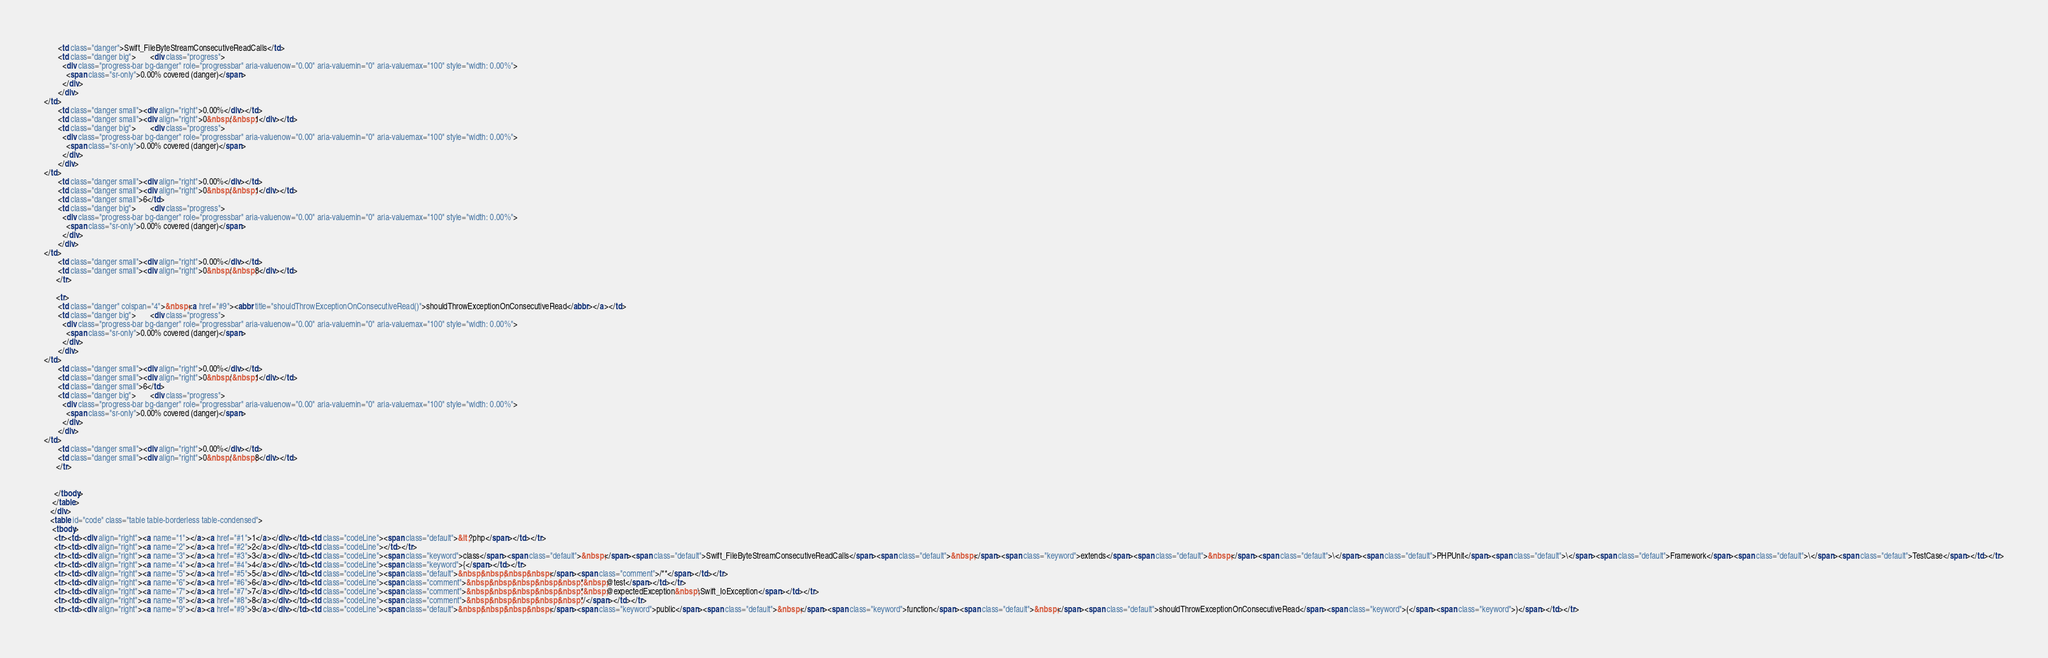Convert code to text. <code><loc_0><loc_0><loc_500><loc_500><_HTML_>       <td class="danger">Swift_FileByteStreamConsecutiveReadCalls</td>
       <td class="danger big">       <div class="progress">
         <div class="progress-bar bg-danger" role="progressbar" aria-valuenow="0.00" aria-valuemin="0" aria-valuemax="100" style="width: 0.00%">
           <span class="sr-only">0.00% covered (danger)</span>
         </div>
       </div>
</td>
       <td class="danger small"><div align="right">0.00%</div></td>
       <td class="danger small"><div align="right">0&nbsp;/&nbsp;1</div></td>
       <td class="danger big">       <div class="progress">
         <div class="progress-bar bg-danger" role="progressbar" aria-valuenow="0.00" aria-valuemin="0" aria-valuemax="100" style="width: 0.00%">
           <span class="sr-only">0.00% covered (danger)</span>
         </div>
       </div>
</td>
       <td class="danger small"><div align="right">0.00%</div></td>
       <td class="danger small"><div align="right">0&nbsp;/&nbsp;1</div></td>
       <td class="danger small">6</td>
       <td class="danger big">       <div class="progress">
         <div class="progress-bar bg-danger" role="progressbar" aria-valuenow="0.00" aria-valuemin="0" aria-valuemax="100" style="width: 0.00%">
           <span class="sr-only">0.00% covered (danger)</span>
         </div>
       </div>
</td>
       <td class="danger small"><div align="right">0.00%</div></td>
       <td class="danger small"><div align="right">0&nbsp;/&nbsp;8</div></td>
      </tr>

      <tr>
       <td class="danger" colspan="4">&nbsp;<a href="#9"><abbr title="shouldThrowExceptionOnConsecutiveRead()">shouldThrowExceptionOnConsecutiveRead</abbr></a></td>
       <td class="danger big">       <div class="progress">
         <div class="progress-bar bg-danger" role="progressbar" aria-valuenow="0.00" aria-valuemin="0" aria-valuemax="100" style="width: 0.00%">
           <span class="sr-only">0.00% covered (danger)</span>
         </div>
       </div>
</td>
       <td class="danger small"><div align="right">0.00%</div></td>
       <td class="danger small"><div align="right">0&nbsp;/&nbsp;1</div></td>
       <td class="danger small">6</td>
       <td class="danger big">       <div class="progress">
         <div class="progress-bar bg-danger" role="progressbar" aria-valuenow="0.00" aria-valuemin="0" aria-valuemax="100" style="width: 0.00%">
           <span class="sr-only">0.00% covered (danger)</span>
         </div>
       </div>
</td>
       <td class="danger small"><div align="right">0.00%</div></td>
       <td class="danger small"><div align="right">0&nbsp;/&nbsp;8</div></td>
      </tr>


     </tbody>
    </table>
   </div>
   <table id="code" class="table table-borderless table-condensed">
    <tbody>
     <tr><td><div align="right"><a name="1"></a><a href="#1">1</a></div></td><td class="codeLine"><span class="default">&lt;?php</span></td></tr>
     <tr><td><div align="right"><a name="2"></a><a href="#2">2</a></div></td><td class="codeLine"></td></tr>
     <tr><td><div align="right"><a name="3"></a><a href="#3">3</a></div></td><td class="codeLine"><span class="keyword">class</span><span class="default">&nbsp;</span><span class="default">Swift_FileByteStreamConsecutiveReadCalls</span><span class="default">&nbsp;</span><span class="keyword">extends</span><span class="default">&nbsp;</span><span class="default">\</span><span class="default">PHPUnit</span><span class="default">\</span><span class="default">Framework</span><span class="default">\</span><span class="default">TestCase</span></td></tr>
     <tr><td><div align="right"><a name="4"></a><a href="#4">4</a></div></td><td class="codeLine"><span class="keyword">{</span></td></tr>
     <tr><td><div align="right"><a name="5"></a><a href="#5">5</a></div></td><td class="codeLine"><span class="default">&nbsp;&nbsp;&nbsp;&nbsp;</span><span class="comment">/**</span></td></tr>
     <tr><td><div align="right"><a name="6"></a><a href="#6">6</a></div></td><td class="codeLine"><span class="comment">&nbsp;&nbsp;&nbsp;&nbsp;&nbsp;*&nbsp;@test</span></td></tr>
     <tr><td><div align="right"><a name="7"></a><a href="#7">7</a></div></td><td class="codeLine"><span class="comment">&nbsp;&nbsp;&nbsp;&nbsp;&nbsp;*&nbsp;@expectedException&nbsp;\Swift_IoException</span></td></tr>
     <tr><td><div align="right"><a name="8"></a><a href="#8">8</a></div></td><td class="codeLine"><span class="comment">&nbsp;&nbsp;&nbsp;&nbsp;&nbsp;*/</span></td></tr>
     <tr><td><div align="right"><a name="9"></a><a href="#9">9</a></div></td><td class="codeLine"><span class="default">&nbsp;&nbsp;&nbsp;&nbsp;</span><span class="keyword">public</span><span class="default">&nbsp;</span><span class="keyword">function</span><span class="default">&nbsp;</span><span class="default">shouldThrowExceptionOnConsecutiveRead</span><span class="keyword">(</span><span class="keyword">)</span></td></tr></code> 